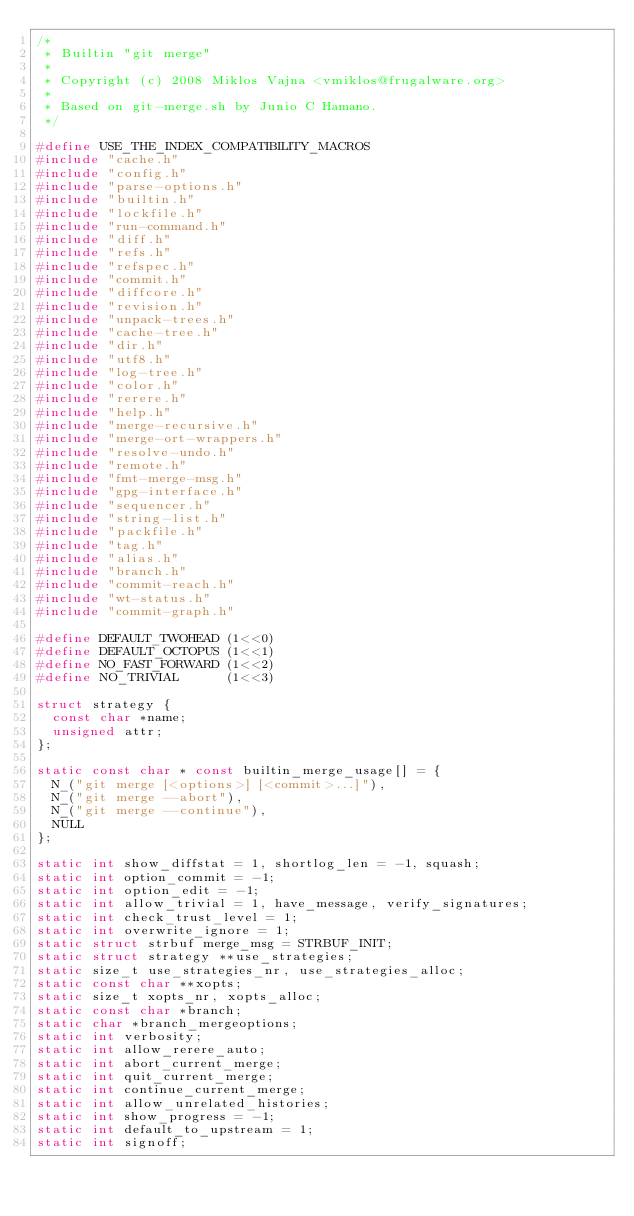<code> <loc_0><loc_0><loc_500><loc_500><_C_>/*
 * Builtin "git merge"
 *
 * Copyright (c) 2008 Miklos Vajna <vmiklos@frugalware.org>
 *
 * Based on git-merge.sh by Junio C Hamano.
 */

#define USE_THE_INDEX_COMPATIBILITY_MACROS
#include "cache.h"
#include "config.h"
#include "parse-options.h"
#include "builtin.h"
#include "lockfile.h"
#include "run-command.h"
#include "diff.h"
#include "refs.h"
#include "refspec.h"
#include "commit.h"
#include "diffcore.h"
#include "revision.h"
#include "unpack-trees.h"
#include "cache-tree.h"
#include "dir.h"
#include "utf8.h"
#include "log-tree.h"
#include "color.h"
#include "rerere.h"
#include "help.h"
#include "merge-recursive.h"
#include "merge-ort-wrappers.h"
#include "resolve-undo.h"
#include "remote.h"
#include "fmt-merge-msg.h"
#include "gpg-interface.h"
#include "sequencer.h"
#include "string-list.h"
#include "packfile.h"
#include "tag.h"
#include "alias.h"
#include "branch.h"
#include "commit-reach.h"
#include "wt-status.h"
#include "commit-graph.h"

#define DEFAULT_TWOHEAD (1<<0)
#define DEFAULT_OCTOPUS (1<<1)
#define NO_FAST_FORWARD (1<<2)
#define NO_TRIVIAL      (1<<3)

struct strategy {
	const char *name;
	unsigned attr;
};

static const char * const builtin_merge_usage[] = {
	N_("git merge [<options>] [<commit>...]"),
	N_("git merge --abort"),
	N_("git merge --continue"),
	NULL
};

static int show_diffstat = 1, shortlog_len = -1, squash;
static int option_commit = -1;
static int option_edit = -1;
static int allow_trivial = 1, have_message, verify_signatures;
static int check_trust_level = 1;
static int overwrite_ignore = 1;
static struct strbuf merge_msg = STRBUF_INIT;
static struct strategy **use_strategies;
static size_t use_strategies_nr, use_strategies_alloc;
static const char **xopts;
static size_t xopts_nr, xopts_alloc;
static const char *branch;
static char *branch_mergeoptions;
static int verbosity;
static int allow_rerere_auto;
static int abort_current_merge;
static int quit_current_merge;
static int continue_current_merge;
static int allow_unrelated_histories;
static int show_progress = -1;
static int default_to_upstream = 1;
static int signoff;</code> 